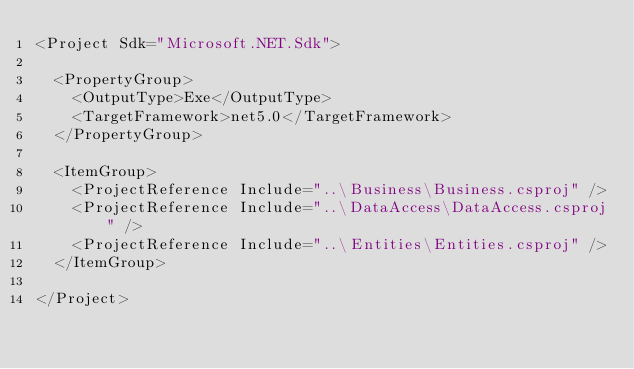<code> <loc_0><loc_0><loc_500><loc_500><_XML_><Project Sdk="Microsoft.NET.Sdk">

  <PropertyGroup>
    <OutputType>Exe</OutputType>
    <TargetFramework>net5.0</TargetFramework>
  </PropertyGroup>

  <ItemGroup>
    <ProjectReference Include="..\Business\Business.csproj" />
    <ProjectReference Include="..\DataAccess\DataAccess.csproj" />
    <ProjectReference Include="..\Entities\Entities.csproj" />
  </ItemGroup>

</Project>
</code> 